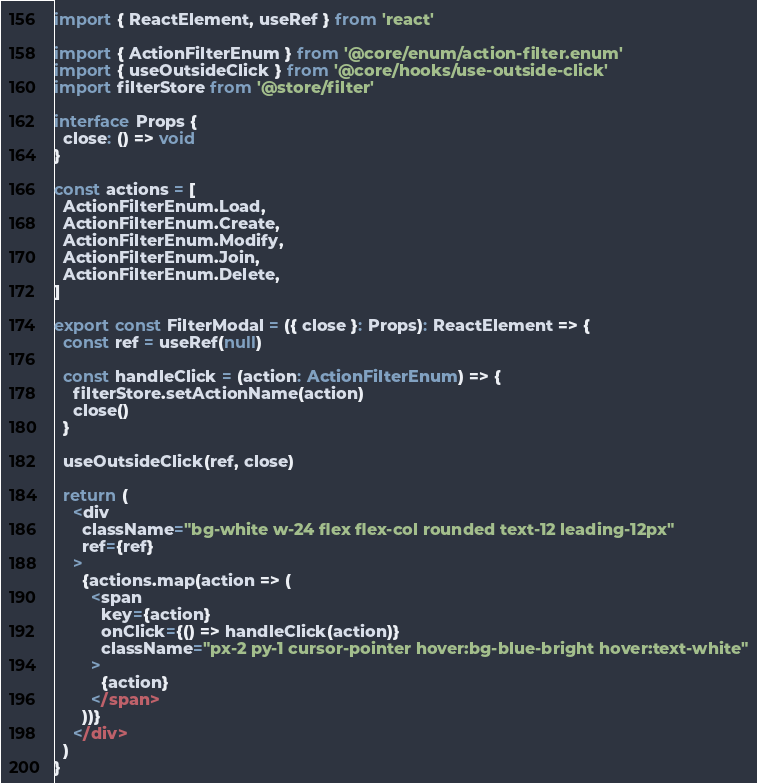<code> <loc_0><loc_0><loc_500><loc_500><_TypeScript_>import { ReactElement, useRef } from 'react'

import { ActionFilterEnum } from '@core/enum/action-filter.enum'
import { useOutsideClick } from '@core/hooks/use-outside-click'
import filterStore from '@store/filter'

interface Props {
  close: () => void
}

const actions = [
  ActionFilterEnum.Load,
  ActionFilterEnum.Create,
  ActionFilterEnum.Modify,
  ActionFilterEnum.Join,
  ActionFilterEnum.Delete,
]

export const FilterModal = ({ close }: Props): ReactElement => {
  const ref = useRef(null)

  const handleClick = (action: ActionFilterEnum) => {
    filterStore.setActionName(action)
    close()
  }

  useOutsideClick(ref, close)

  return (
    <div
      className="bg-white w-24 flex flex-col rounded text-12 leading-12px"
      ref={ref}
    >
      {actions.map(action => (
        <span
          key={action}
          onClick={() => handleClick(action)}
          className="px-2 py-1 cursor-pointer hover:bg-blue-bright hover:text-white"
        >
          {action}
        </span>
      ))}
    </div>
  )
}
</code> 